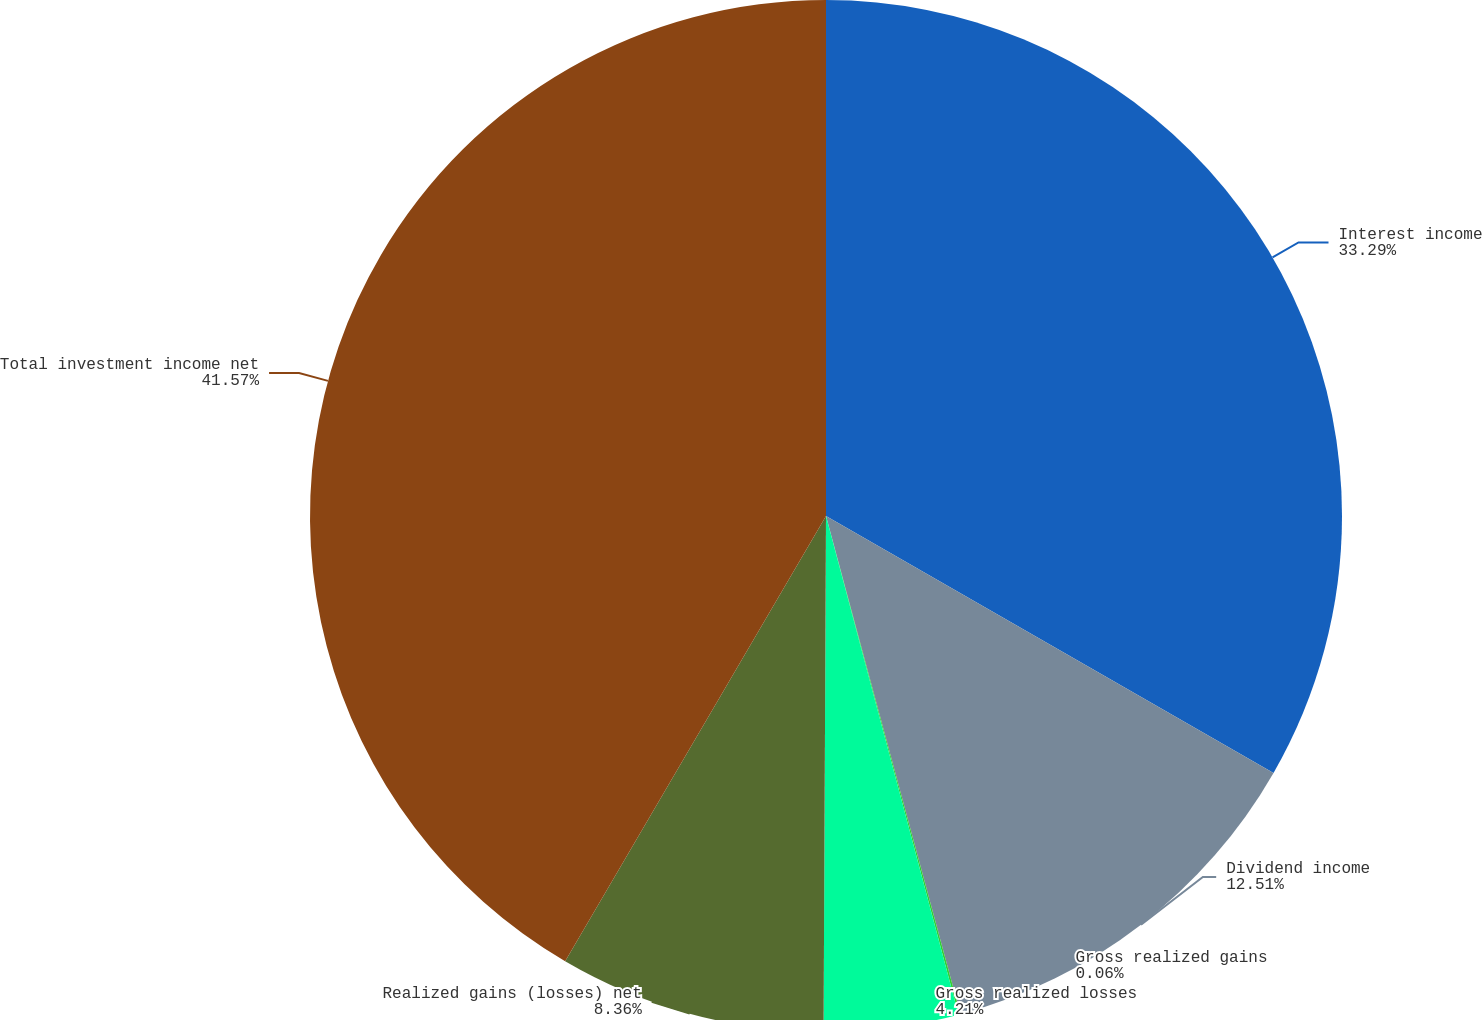Convert chart to OTSL. <chart><loc_0><loc_0><loc_500><loc_500><pie_chart><fcel>Interest income<fcel>Dividend income<fcel>Gross realized gains<fcel>Gross realized losses<fcel>Realized gains (losses) net<fcel>Total investment income net<nl><fcel>33.29%<fcel>12.51%<fcel>0.06%<fcel>4.21%<fcel>8.36%<fcel>41.56%<nl></chart> 